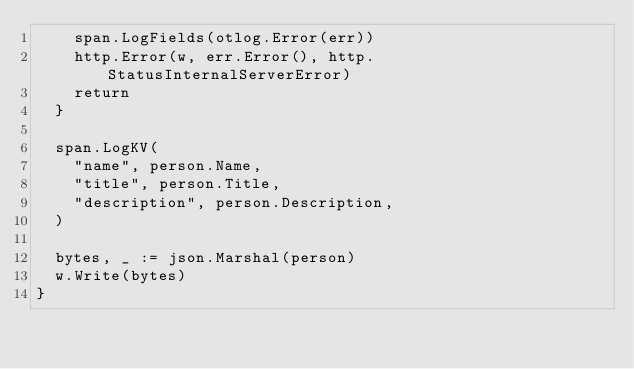Convert code to text. <code><loc_0><loc_0><loc_500><loc_500><_Go_>		span.LogFields(otlog.Error(err))
		http.Error(w, err.Error(), http.StatusInternalServerError)
		return
	}

	span.LogKV(
		"name", person.Name,
		"title", person.Title,
		"description", person.Description,
	)

	bytes, _ := json.Marshal(person)
	w.Write(bytes)
}
</code> 